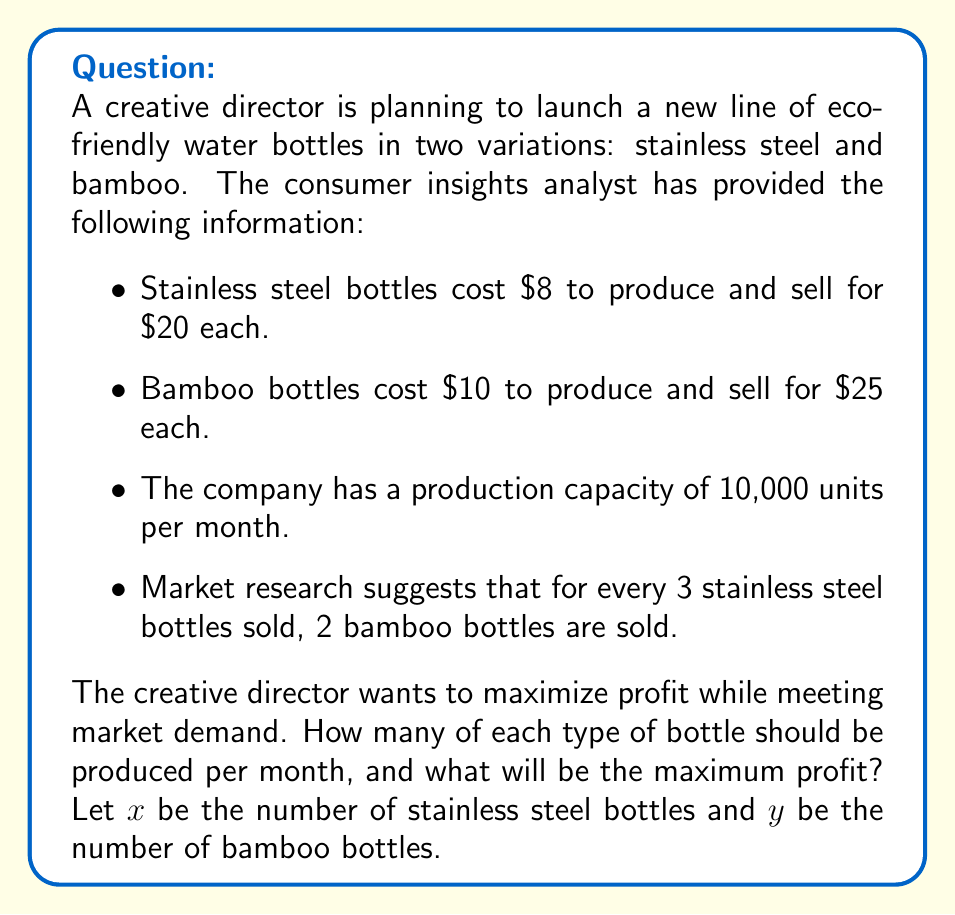Show me your answer to this math problem. To solve this problem, we'll use a system of equations based on the given information:

1. Profit equation:
   Profit = Revenue - Cost
   $$P = 20x + 25y - 8x - 10y = 12x + 15y$$

2. Production capacity constraint:
   $$x + y = 10000$$

3. Market demand ratio:
   $$\frac{x}{y} = \frac{3}{2}$$ or $$3y = 2x$$

Now, let's solve the system of equations:

From equation 3: $$x = \frac{3y}{2}$$

Substitute this into equation 2:
$$\frac{3y}{2} + y = 10000$$
$$\frac{3y + 2y}{2} = 10000$$
$$\frac{5y}{2} = 10000$$
$$y = 4000$$

Now we can find $x$:
$$x = \frac{3(4000)}{2} = 6000$$

To verify, check if $x + y = 10000$:
$$6000 + 4000 = 10000$$ (constraint satisfied)

Now, calculate the maximum profit:
$$P = 12x + 15y = 12(6000) + 15(4000) = 72000 + 60000 = 132000$$
Answer: The company should produce 6,000 stainless steel bottles and 4,000 bamboo bottles per month to maximize profit. The maximum profit will be $132,000 per month. 